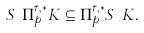Convert formula to latex. <formula><loc_0><loc_0><loc_500><loc_500>S _ { u } \Pi _ { p } ^ { \tau , * } K \subseteq \Pi _ { p } ^ { \tau , * } S _ { u } K .</formula> 